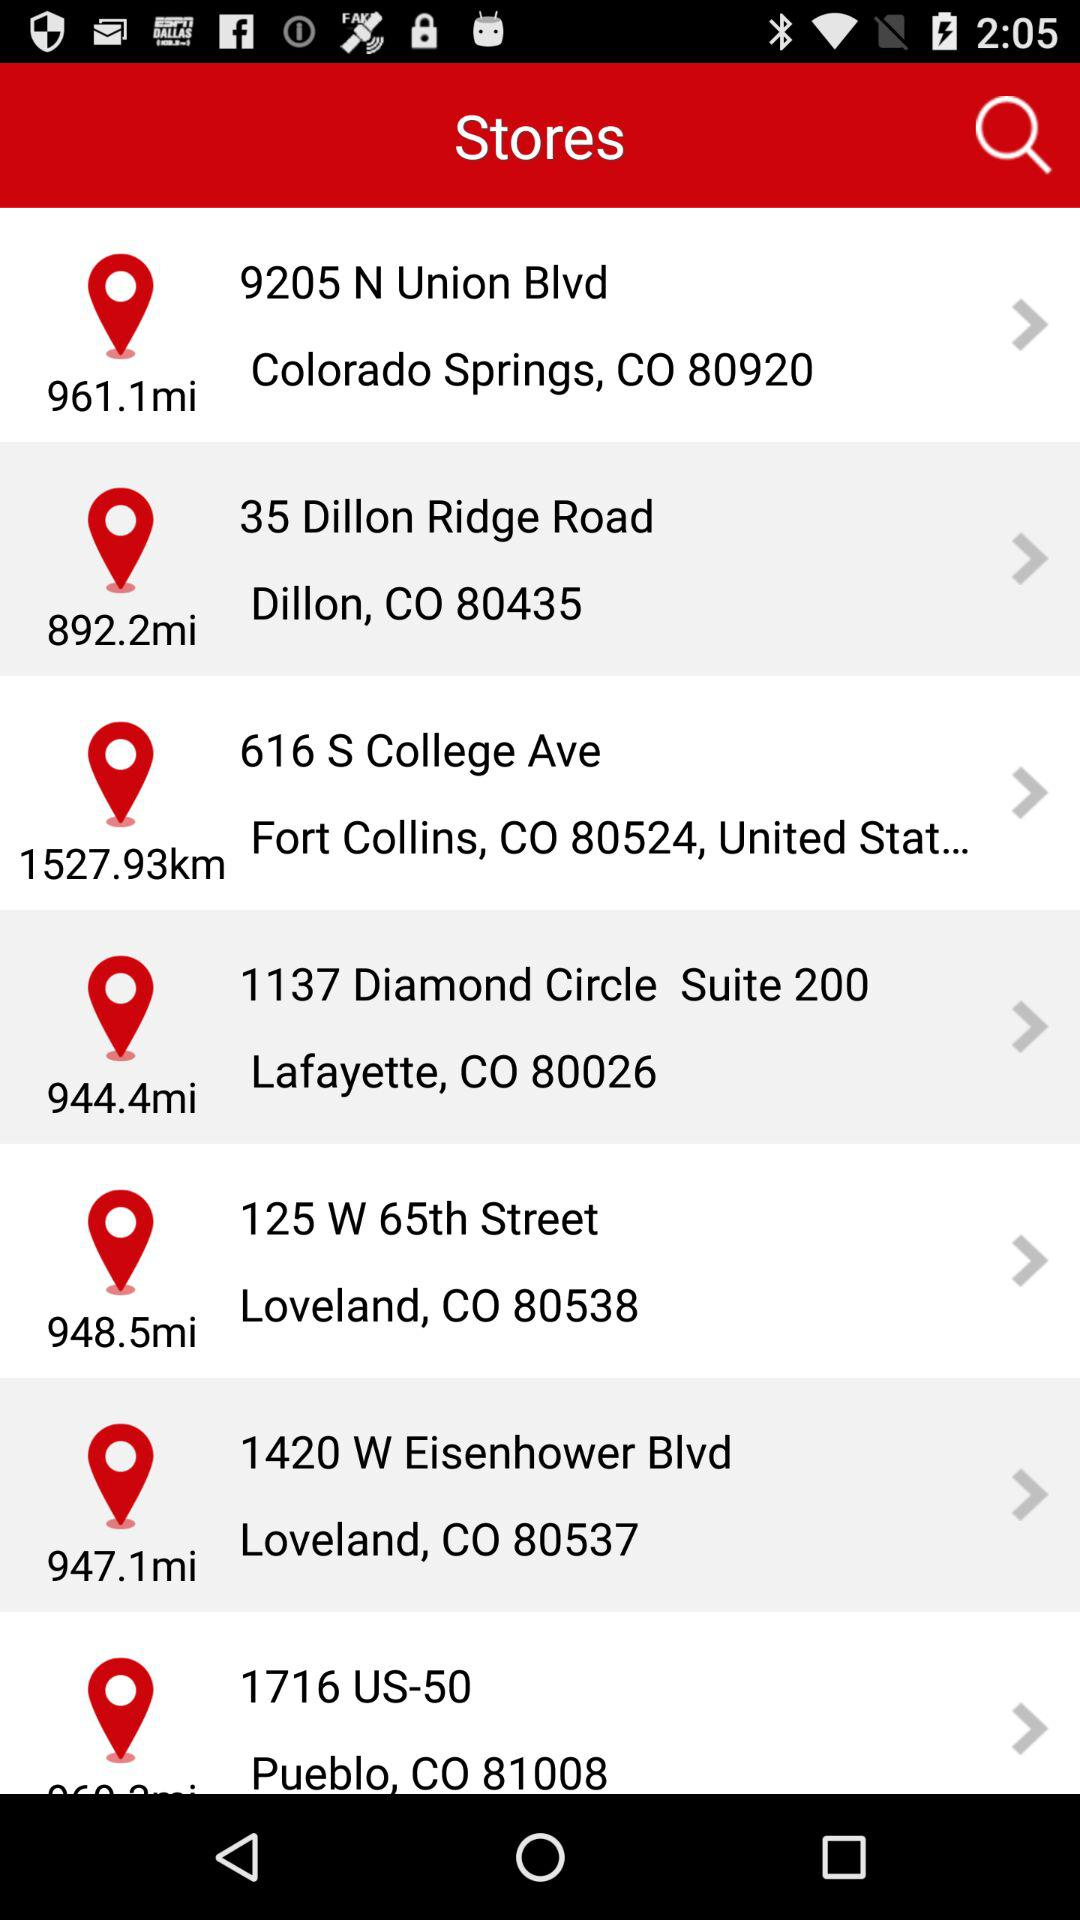How many stores are located within 1000 miles of Colorado Springs?
Answer the question using a single word or phrase. 5 